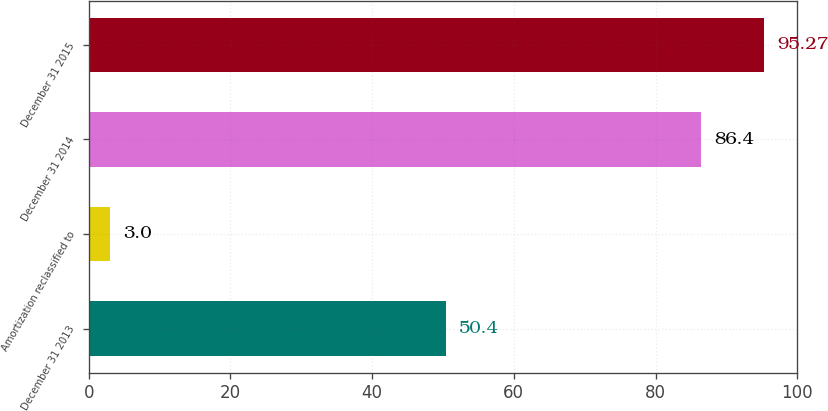Convert chart to OTSL. <chart><loc_0><loc_0><loc_500><loc_500><bar_chart><fcel>December 31 2013<fcel>Amortization reclassified to<fcel>December 31 2014<fcel>December 31 2015<nl><fcel>50.4<fcel>3<fcel>86.4<fcel>95.27<nl></chart> 